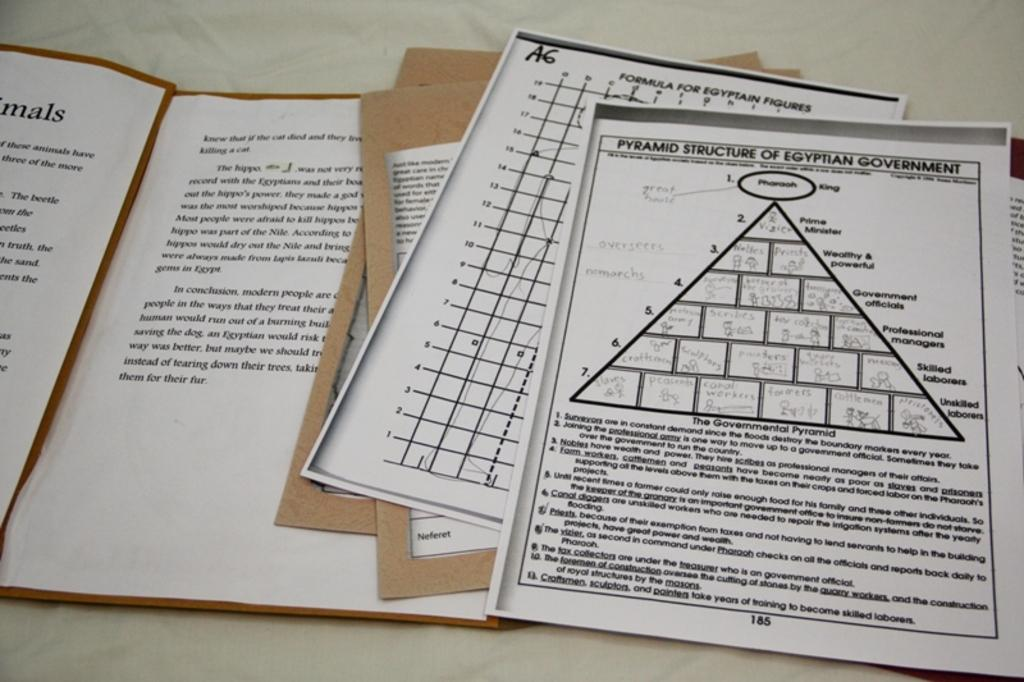<image>
Give a short and clear explanation of the subsequent image. One of the several pieces of paper is about the pyramid structure of Egyptian government 